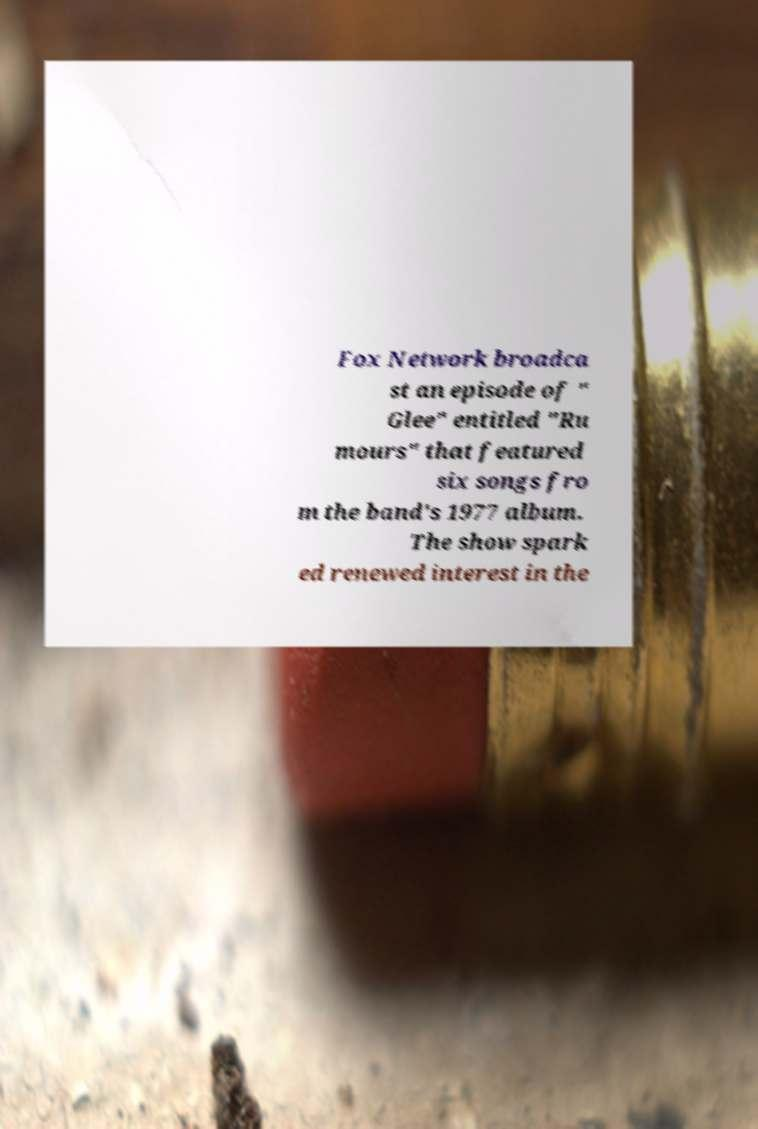Could you assist in decoding the text presented in this image and type it out clearly? Fox Network broadca st an episode of " Glee" entitled "Ru mours" that featured six songs fro m the band's 1977 album. The show spark ed renewed interest in the 